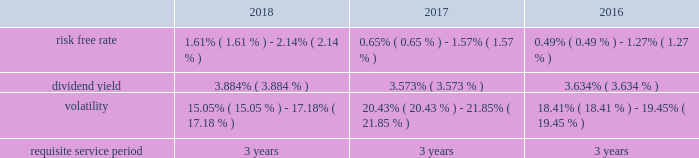Stock based compensation overview maa accounts for its stock based employee compensation plans in accordance with accounting standards governing stock based compensation .
These standards require an entity to measure the cost of employee services received in exchange for an award of an equity instrument based on the award's fair value on the grant date and recognize the cost over the period during which the employee is required to provide service in exchange for the award , which is generally the vesting period .
Any liability awards issued are remeasured at each reporting period .
Maa 2019s stock compensation plans consist of a number of incentives provided to attract and retain independent directors , executive officers and key employees .
Incentives are currently granted under the second amended and restated 2013 stock incentive plan , or the stock plan , which was approved at the 2018 annual meeting of maa shareholders .
The stock plan allows for the grant of restricted stock and stock options up to 2000000 shares .
Maa believes that such awards better align the interests of its employees with those of its shareholders .
Compensation expense is generally recognized for service based restricted stock awards using the straight-line method over the vesting period of the shares regardless of cliff or ratable vesting distinctions .
Compensation expense for market and performance based restricted stock awards is generally recognized using the accelerated amortization method with each vesting tranche valued as a separate award , with a separate vesting date , consistent with the estimated value of the award at each period end .
Additionally , compensation expense is adjusted for actual forfeitures for all awards in the period that the award was forfeited .
Compensation expense for stock options is generally recognized on a straight-line basis over the requisite service period .
Maa presents stock compensation expense in the consolidated statements of operations in "general and administrative expenses" .
Total compensation expense under the stock plan was $ 12.9 million , $ 10.8 million and $ 12.2 million for the years ended december 31 , 2018 , 2017 and 2016 , respectively .
Of these amounts , total compensation expense capitalized was $ 0.5 million , $ 0.2 million and $ 0.7 million for the years ended december 31 , 2018 , 2017 and 2016 , respectively .
As of december 31 , 2018 , the total unrecognized compensation expense was $ 13.5 million .
This cost is expected to be recognized over the remaining weighted average period of 1.1 years .
Total cash paid for the settlement of plan shares totaled $ 2.9 million , $ 4.8 million and $ 2.0 million for the years ended december 31 , 2018 , 2017 and 2016 , respectively .
Information concerning grants under the stock plan is provided below .
Restricted stock in general , restricted stock is earned based on either a service condition , performance condition , or market condition , or a combination thereof , and generally vests ratably over a period from 1 year to 5 years .
Service based awards are earned when the employee remains employed over the requisite service period and are valued on the grant date based upon the market price of maa common stock on the date of grant .
Market based awards are earned when maa reaches a specified stock price or specified return on the stock price ( price appreciation plus dividends ) and are valued on the grant date using a monte carlo simulation .
Performance based awards are earned when maa reaches certain operational goals such as funds from operations , or ffo , targets and are valued based upon the market price of maa common stock on the date of grant as well as the probability of reaching the stated targets .
Maa remeasures the fair value of the performance based awards each balance sheet date with adjustments made on a cumulative basis until the award is settled and the final compensation is known .
The weighted average grant date fair value per share of restricted stock awards granted during the years ended december 31 , 2018 , 2017 and 2016 , was $ 71.85 , $ 84.53 and $ 73.20 , respectively .
The following is a summary of the key assumptions used in the valuation calculations for market based awards granted during the years ended december 31 , 2018 , 2017 and 2016: .
The risk free rate was based on a zero coupon risk-free rate .
The minimum risk free rate was based on a period of 0.25 years for the years ended december 31 , 2018 , 2017 and 2016 .
The maximum risk free rate was based on a period of 3 years for the years ended december 31 , 2018 , 2017 and 2016 .
The dividend yield was based on the closing stock price of maa stock on the .
Considering the year 2018 , what is the average risk-free rate? 
Rationale: it is the sum of the low and high risk-free rates divided by two to represent the average .
Computations: ((1.61% + 2.14%) / 2)
Answer: 0.01875. 